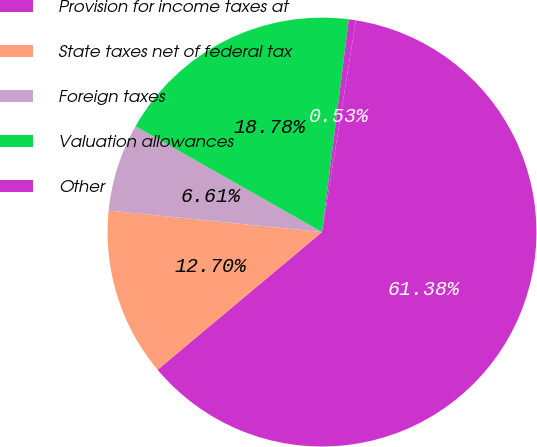Convert chart to OTSL. <chart><loc_0><loc_0><loc_500><loc_500><pie_chart><fcel>Provision for income taxes at<fcel>State taxes net of federal tax<fcel>Foreign taxes<fcel>Valuation allowances<fcel>Other<nl><fcel>61.38%<fcel>12.7%<fcel>6.61%<fcel>18.78%<fcel>0.53%<nl></chart> 